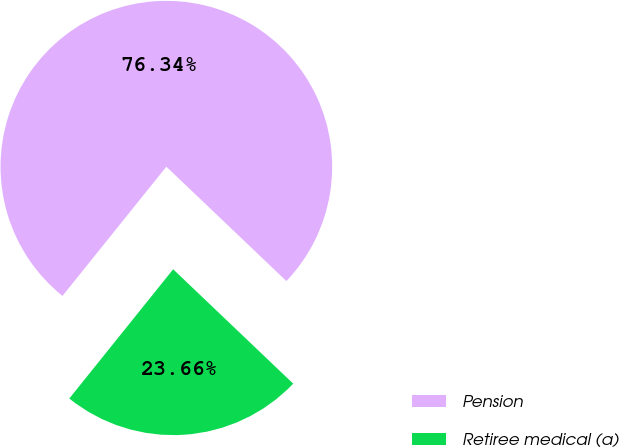<chart> <loc_0><loc_0><loc_500><loc_500><pie_chart><fcel>Pension<fcel>Retiree medical (a)<nl><fcel>76.34%<fcel>23.66%<nl></chart> 